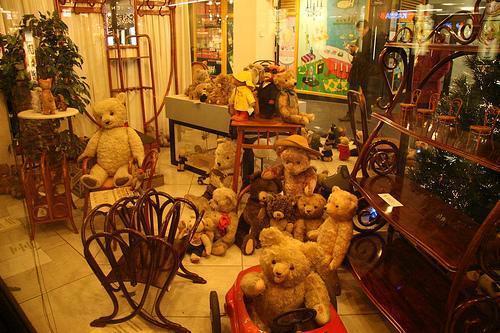How many chairs are on the shelf?
Give a very brief answer. 4. How many teddy bears can you see?
Give a very brief answer. 4. 